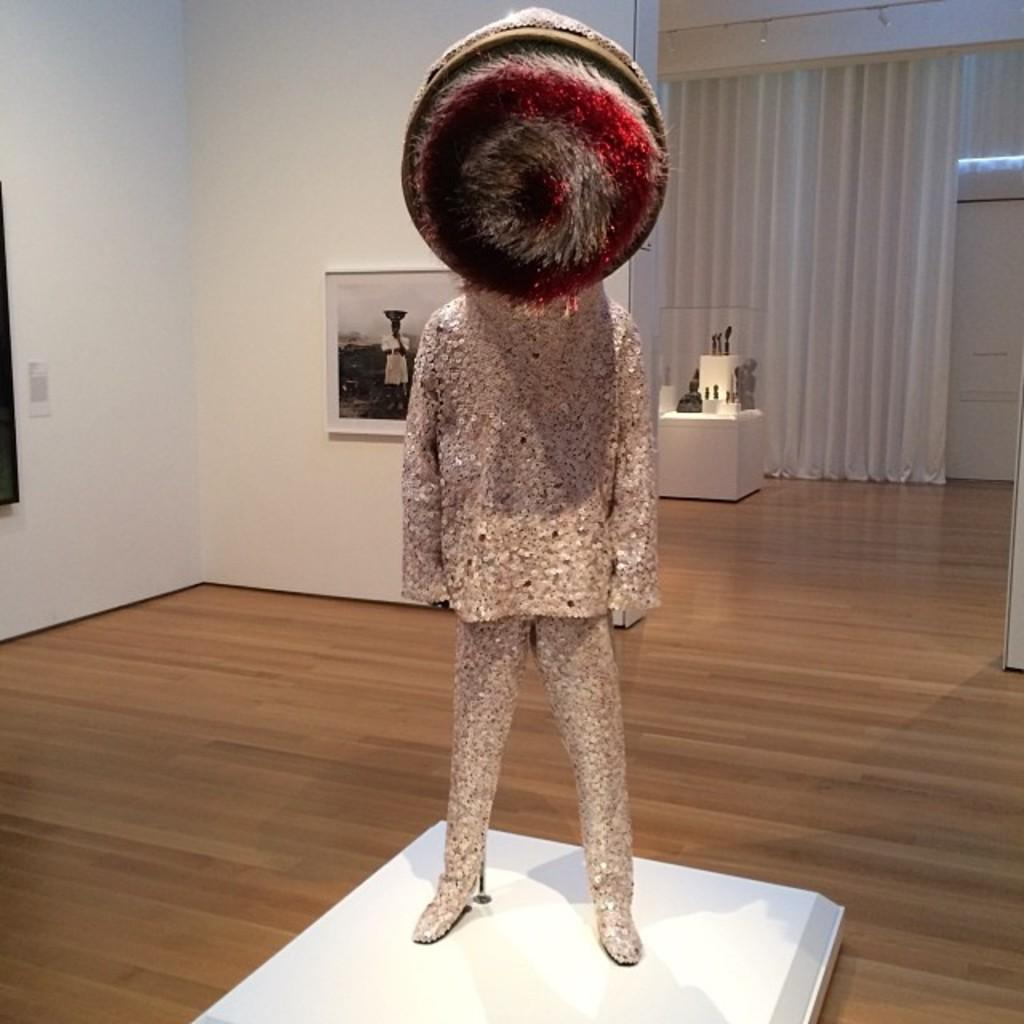What type of artwork can be seen in the room? There is a sculpture in the room. What is hanging on the wall in the room? There is a frame on the wall in the room. What other items can be seen in the room besides the sculpture and frame? There are other objects visible in the room. How many sacks are being pulled by the sculpture in the room? There are no sacks or any indication of pulling in the image; it only shows a sculpture and a frame on the wall. 